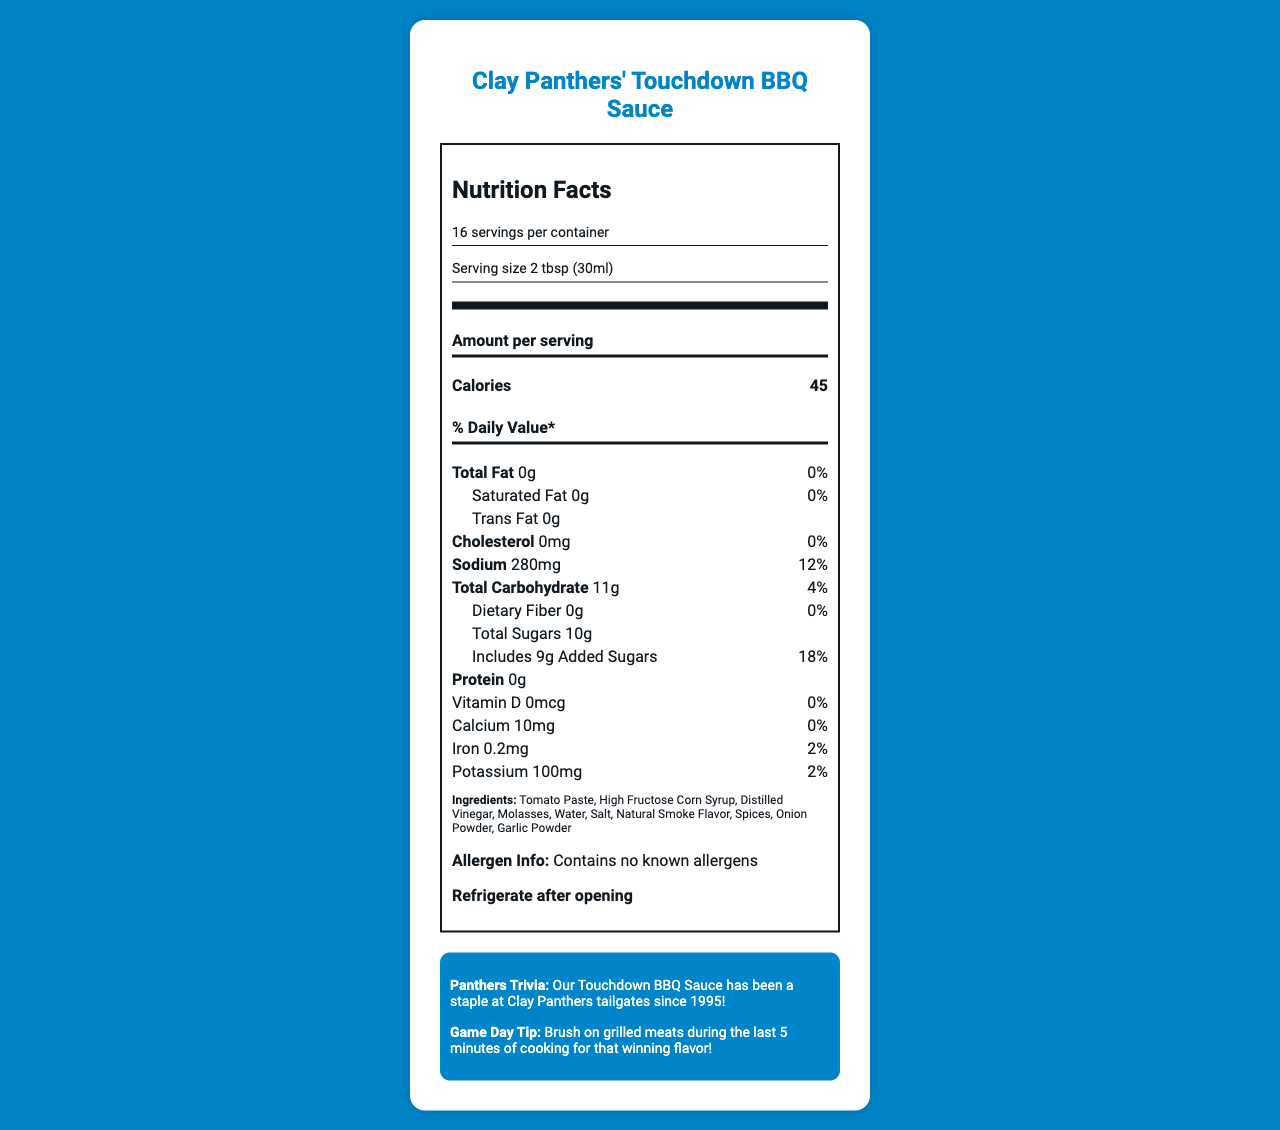what is the serving size? The serving size is listed as "2 tbsp (30ml)" in the document.
Answer: 2 tbsp (30ml) how many calories are in one serving? The document states that there are 45 calories per serving.
Answer: 45 calories what percentage daily value of sodium does one serving contain? The sodium content per serving is listed as 280mg, which is 12% of the daily value.
Answer: 12% what is the total carbohydrate amount in one serving? The total carbohydrate content per serving is listed as 11g.
Answer: 11g what are the first three ingredients? The first three ingredients mentioned are Tomato Paste, High Fructose Corn Syrup, and Distilled Vinegar.
Answer: Tomato Paste, High Fructose Corn Syrup, Distilled Vinegar what is the total fat content per serving? The document states that the total fat content per serving is 0g.
Answer: 0g does this product contain any allergens? The allergen info states "Contains no known allergens."
Answer: No what should you do after opening the sauce? The document clearly instructs to refrigerate after opening.
Answer: Refrigerate after opening how long has the BBQ sauce been a staple at Clay Panthers tailgates? The document mentions that the Touchdown BBQ Sauce has been a staple at Clay Panthers tailgates since 1995.
Answer: Since 1995 (Multiple-choice) how much protein does one serving contain?
A. 0g
B. 1g
C. 2g
D. 3g The document states that one serving contains 0g of protein.
Answer: A (Multiple-choice) what is the recommended game day tip for using the BBQ sauce?
I. Brush on meats during the last 5 minutes of cooking
II. Use as a dipping sauce
III. Mix it into your favorite marinade The document’s game day tip recommends brushing the sauce on grilled meats during the last 5 minutes of cooking.
Answer: I (True/False) this product has 0mg of cholesterol per serving. According to the document, the cholesterol amount per serving is 0mg.
Answer: True summarize the main information of the document. The document features detailed nutritional information, ingredients, allergen information, and storage instructions for the BBQ sauce, as well as fun trivia and a useful cooking tip related to the Panthers.
Answer: The document provides the nutrition facts for Clay Panthers' Touchdown BBQ Sauce, including serving size, calories, and nutrient percentages. It lists the ingredients, states that there are no known allergens, and offers storage instructions. Additionally, it includes a Panthers trivia and a game day tip. what are the benefits of using this sauce for people following a low-fat diet? The document provides nutritional information but not a detailed analysis of health benefits for specific diets such as low-fat.
Answer: Not enough information 